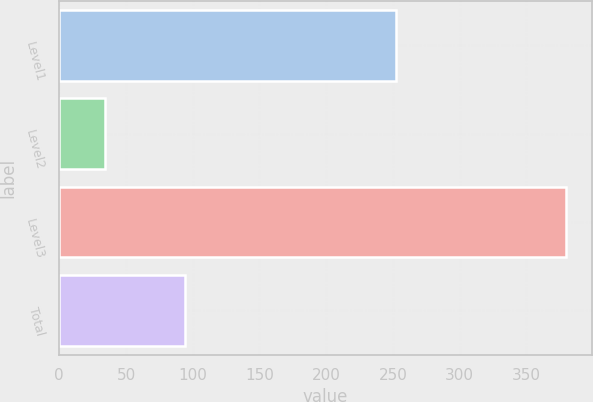Convert chart. <chart><loc_0><loc_0><loc_500><loc_500><bar_chart><fcel>Level1<fcel>Level2<fcel>Level3<fcel>Total<nl><fcel>252<fcel>34<fcel>380<fcel>94<nl></chart> 